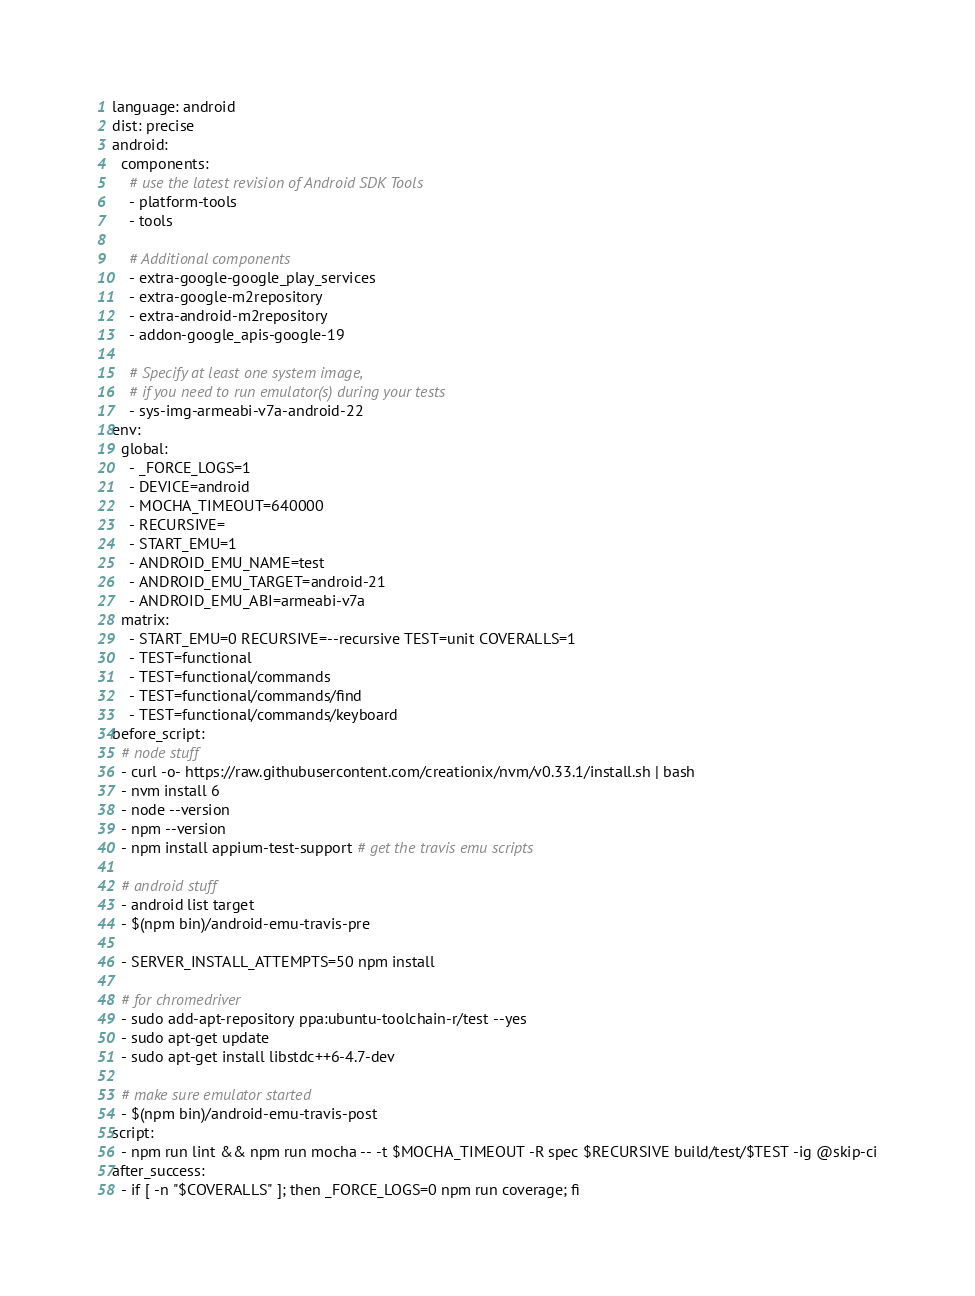<code> <loc_0><loc_0><loc_500><loc_500><_YAML_>language: android
dist: precise
android:
  components:
    # use the latest revision of Android SDK Tools
    - platform-tools
    - tools

    # Additional components
    - extra-google-google_play_services
    - extra-google-m2repository
    - extra-android-m2repository
    - addon-google_apis-google-19

    # Specify at least one system image,
    # if you need to run emulator(s) during your tests
    - sys-img-armeabi-v7a-android-22
env:
  global:
    - _FORCE_LOGS=1
    - DEVICE=android
    - MOCHA_TIMEOUT=640000
    - RECURSIVE=
    - START_EMU=1
    - ANDROID_EMU_NAME=test
    - ANDROID_EMU_TARGET=android-21
    - ANDROID_EMU_ABI=armeabi-v7a
  matrix:
    - START_EMU=0 RECURSIVE=--recursive TEST=unit COVERALLS=1
    - TEST=functional
    - TEST=functional/commands
    - TEST=functional/commands/find
    - TEST=functional/commands/keyboard
before_script:
  # node stuff
  - curl -o- https://raw.githubusercontent.com/creationix/nvm/v0.33.1/install.sh | bash
  - nvm install 6
  - node --version
  - npm --version
  - npm install appium-test-support # get the travis emu scripts

  # android stuff
  - android list target
  - $(npm bin)/android-emu-travis-pre

  - SERVER_INSTALL_ATTEMPTS=50 npm install

  # for chromedriver
  - sudo add-apt-repository ppa:ubuntu-toolchain-r/test --yes
  - sudo apt-get update
  - sudo apt-get install libstdc++6-4.7-dev  

  # make sure emulator started
  - $(npm bin)/android-emu-travis-post
script:
  - npm run lint && npm run mocha -- -t $MOCHA_TIMEOUT -R spec $RECURSIVE build/test/$TEST -ig @skip-ci
after_success:
  - if [ -n "$COVERALLS" ]; then _FORCE_LOGS=0 npm run coverage; fi
</code> 